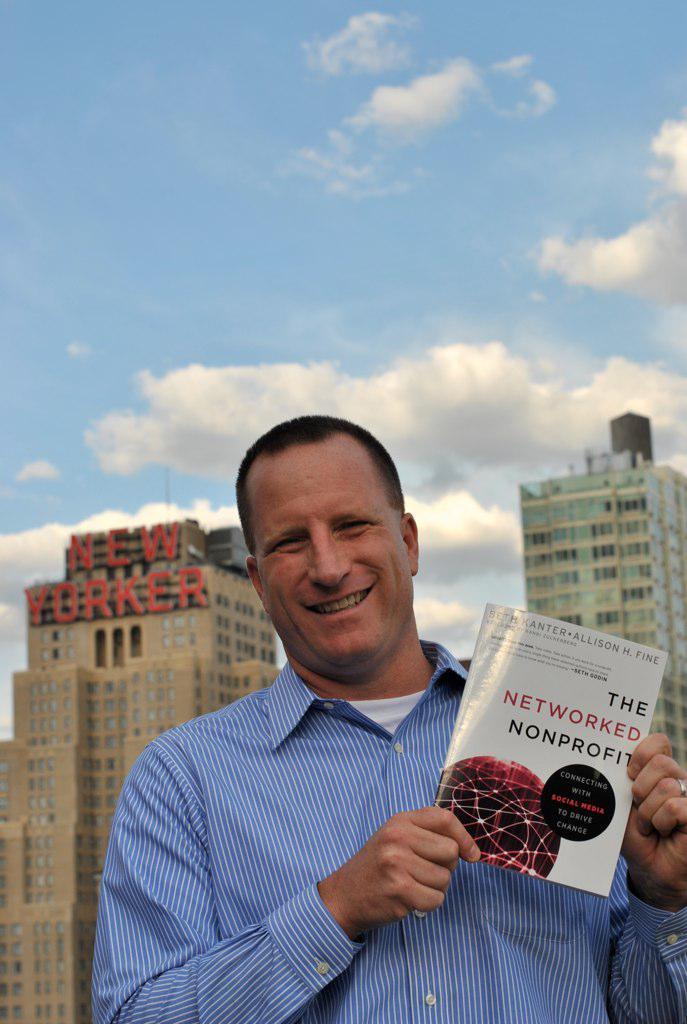What is the title of the book?
Make the answer very short. The networked nonprofit. What publication owns the building in the background?
Your answer should be very brief. New yorker. 